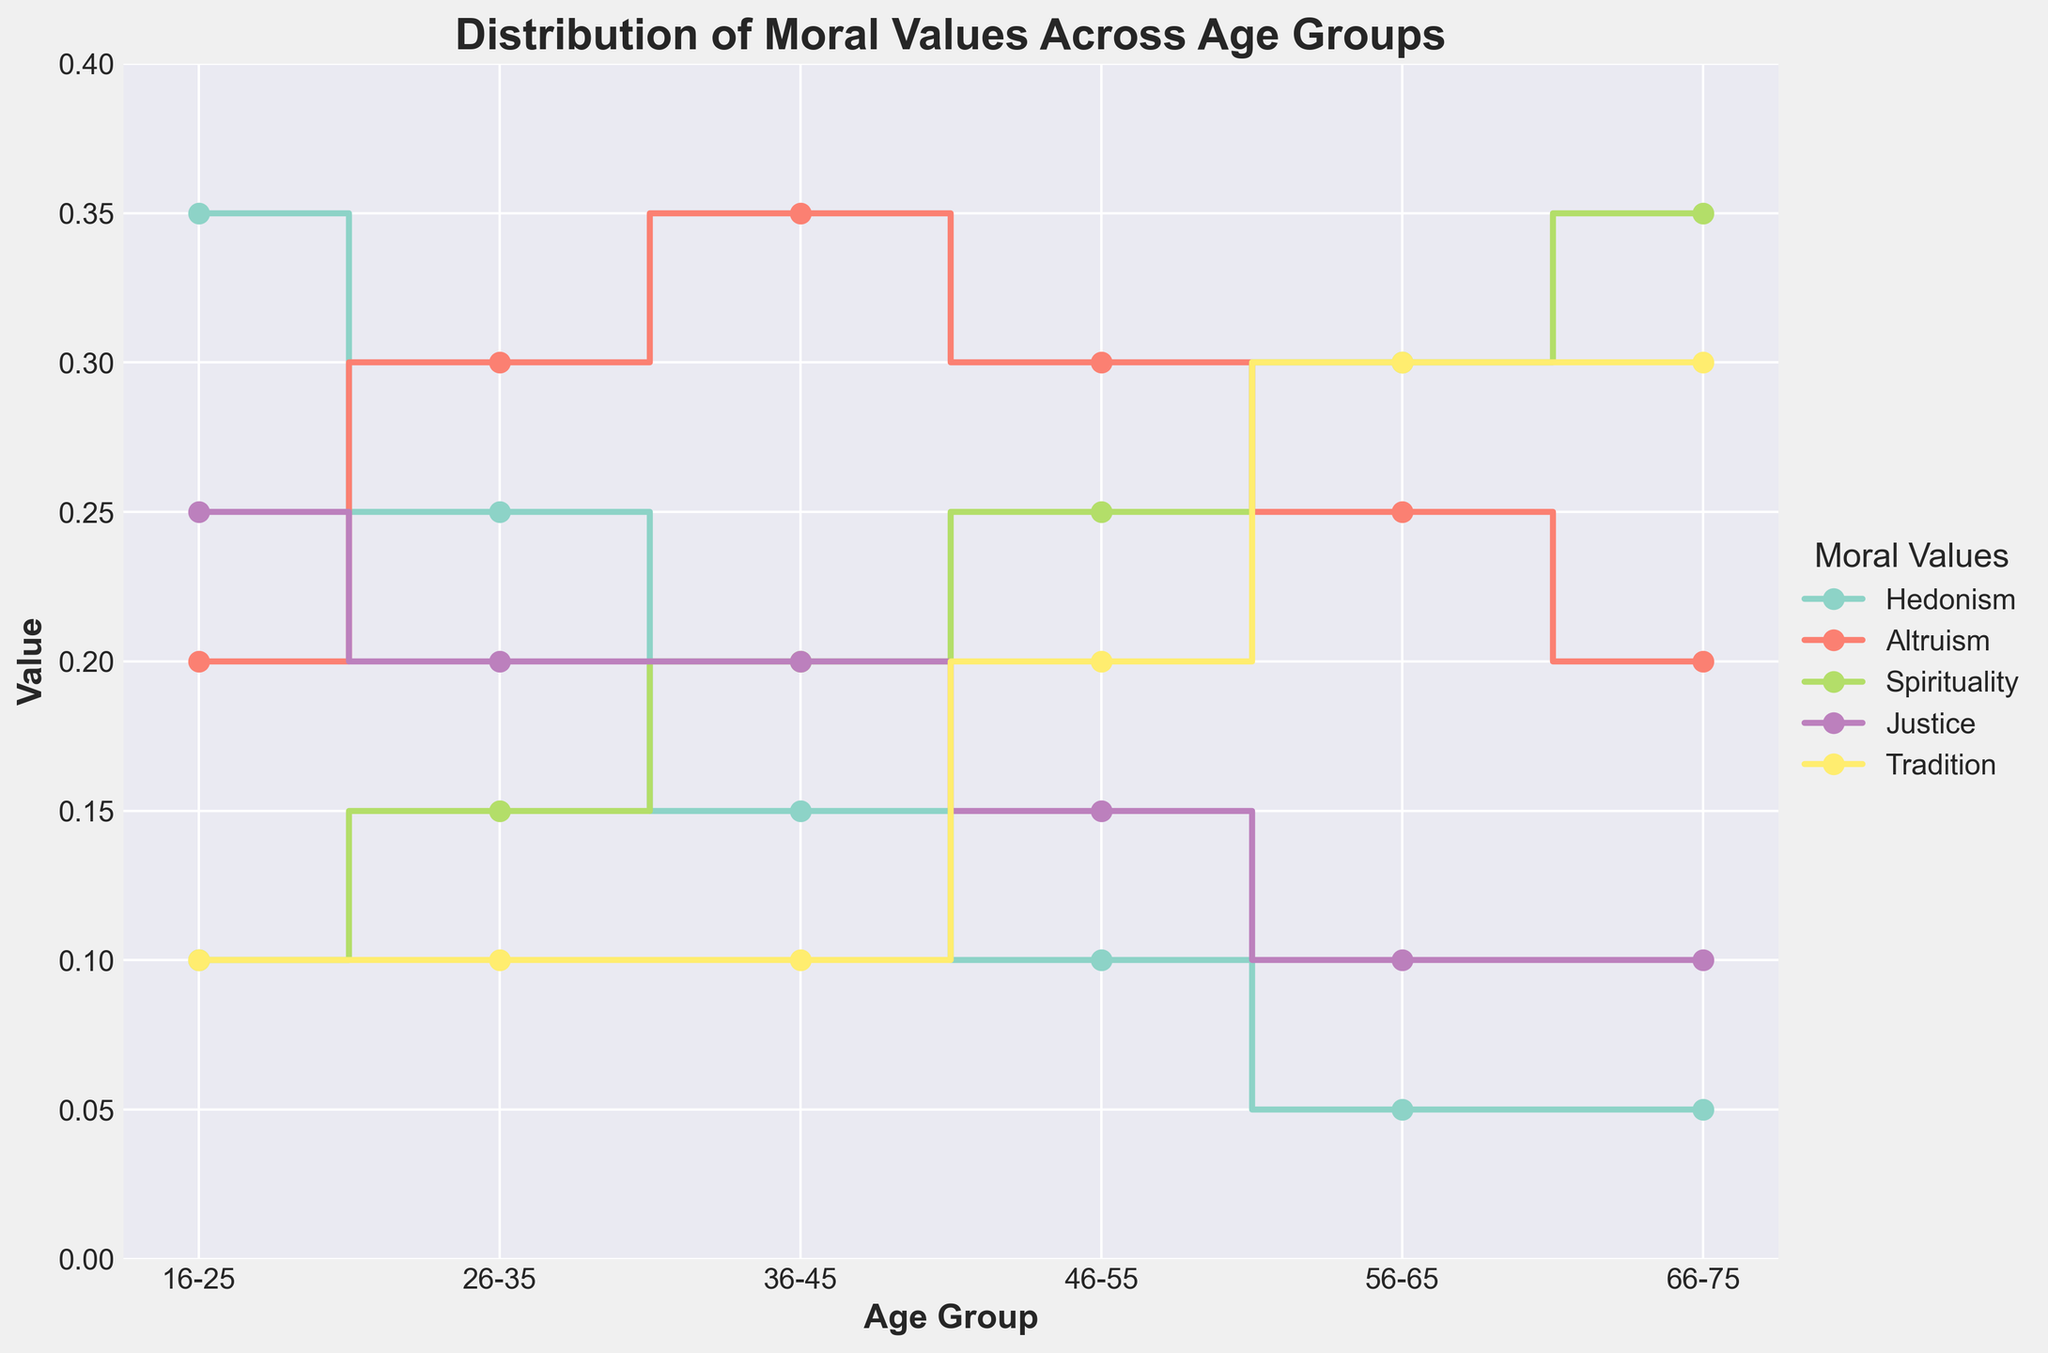What is the overall trend of hedonism from the youngest to the oldest age group? The value of hedonism decreases steadily as age increases, starting from 0.35 in the 16-25 age group to 0.05 in the 66-75 age group.
Answer: It decreases Which age group places the highest value on spirituality? By observing the plot, the 66-75 age group shows the highest value for spirituality at 0.35.
Answer: 66-75 Among the moral values shown, which value exhibits the most consistent (unchanged) trend across age groups? Tradition remains constant at 0.10 for ages 16-25, 26-35, and 36-45, and then increases but stays stable at 0.30 for ages 56-65 and 66-75.
Answer: Tradition How does the value of altruism change from the 16-25 age group to the 36-45 age group? Altruism rises from 0.20 in the 16-25 age group, to 0.30 in the 26-35 age group, and then reaches its peak at 0.35 in the 36-45 age group.
Answer: It increases Which age group has the highest combined value of spirituality and tradition? For each age group, sum the values of spirituality and tradition. The 66-75 age group has the highest combined value of 0.35 (spirituality) + 0.30 (tradition) = 0.65.
Answer: 66-75 Do justice and spirituality have any age groups where their values are equivalent? For each age group, compare the values of justice and spirituality. In the 36-45 age group, both justice and spirituality are valued at 0.20.
Answer: 36-45 What is the difference in value for justice between the youngest and oldest age groups? Subtract the value of justice in the 66-75 age group (0.10) from its value in the 16-25 age group (0.25). The difference is 0.25 - 0.10.
Answer: 0.15 Which age group values hedonism the least? By observing the plot, the 56-65 and 66-75 age groups have the lowest value for hedonism at 0.05.
Answer: 56-65 and 66-75 